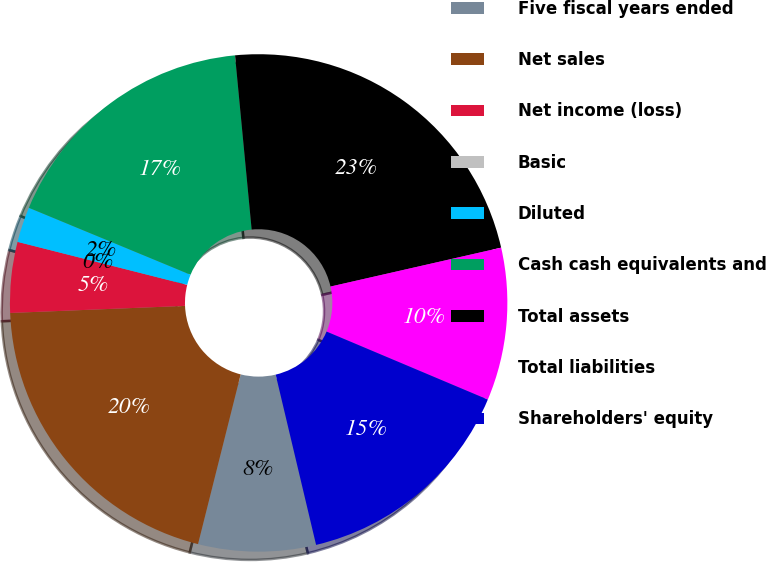<chart> <loc_0><loc_0><loc_500><loc_500><pie_chart><fcel>Five fiscal years ended<fcel>Net sales<fcel>Net income (loss)<fcel>Basic<fcel>Diluted<fcel>Cash cash equivalents and<fcel>Total assets<fcel>Total liabilities<fcel>Shareholders' equity<nl><fcel>7.63%<fcel>20.44%<fcel>4.59%<fcel>0.0%<fcel>2.3%<fcel>17.24%<fcel>22.95%<fcel>9.92%<fcel>14.94%<nl></chart> 